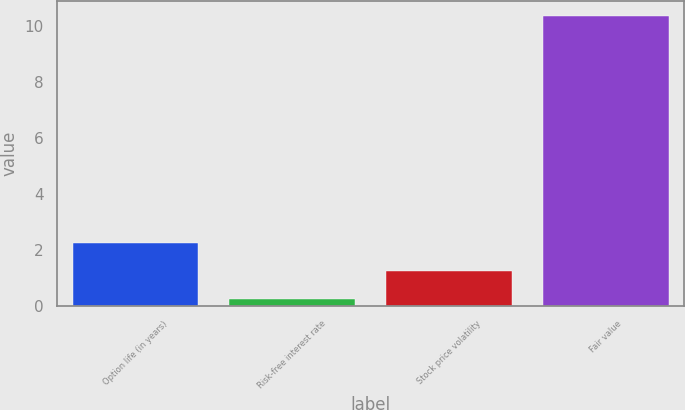Convert chart to OTSL. <chart><loc_0><loc_0><loc_500><loc_500><bar_chart><fcel>Option life (in years)<fcel>Risk-free interest rate<fcel>Stock price volatility<fcel>Fair value<nl><fcel>2.25<fcel>0.23<fcel>1.24<fcel>10.36<nl></chart> 